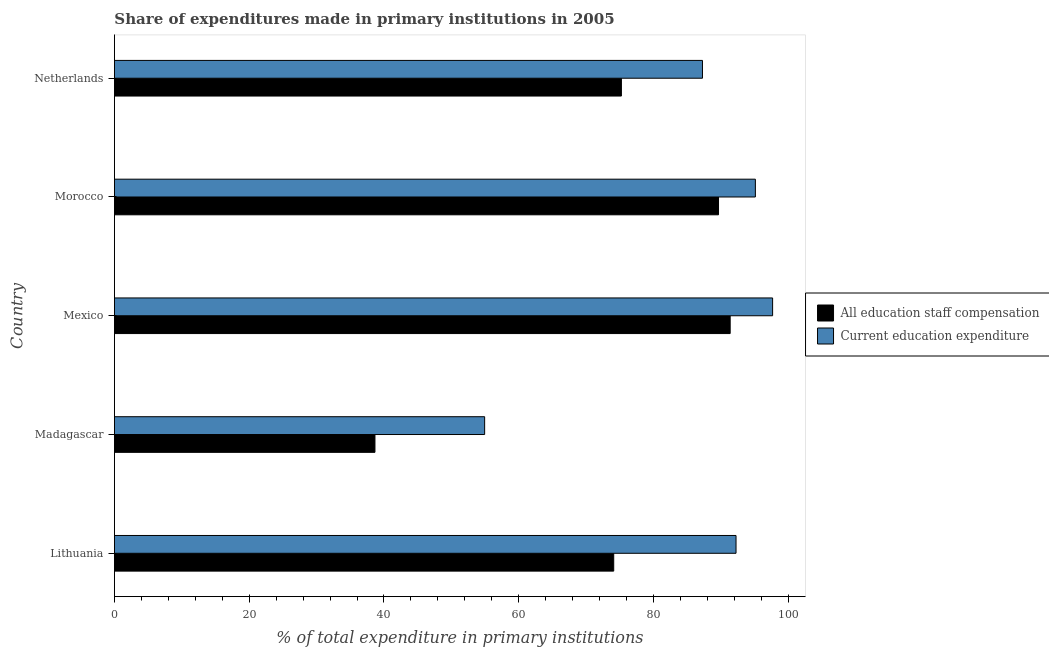How many groups of bars are there?
Your response must be concise. 5. Are the number of bars per tick equal to the number of legend labels?
Ensure brevity in your answer.  Yes. How many bars are there on the 5th tick from the bottom?
Keep it short and to the point. 2. What is the label of the 2nd group of bars from the top?
Give a very brief answer. Morocco. What is the expenditure in staff compensation in Morocco?
Your answer should be very brief. 89.64. Across all countries, what is the maximum expenditure in education?
Keep it short and to the point. 97.67. Across all countries, what is the minimum expenditure in staff compensation?
Keep it short and to the point. 38.66. In which country was the expenditure in staff compensation maximum?
Give a very brief answer. Mexico. In which country was the expenditure in education minimum?
Provide a short and direct response. Madagascar. What is the total expenditure in education in the graph?
Provide a short and direct response. 427.21. What is the difference between the expenditure in staff compensation in Mexico and that in Morocco?
Your response must be concise. 1.73. What is the difference between the expenditure in education in Mexico and the expenditure in staff compensation in Madagascar?
Offer a terse response. 59.01. What is the average expenditure in staff compensation per country?
Give a very brief answer. 73.8. What is the difference between the expenditure in staff compensation and expenditure in education in Lithuania?
Your response must be concise. -18.15. In how many countries, is the expenditure in staff compensation greater than 60 %?
Your answer should be very brief. 4. What is the ratio of the expenditure in staff compensation in Morocco to that in Netherlands?
Provide a short and direct response. 1.19. Is the expenditure in staff compensation in Lithuania less than that in Mexico?
Provide a short and direct response. Yes. What is the difference between the highest and the second highest expenditure in staff compensation?
Give a very brief answer. 1.73. What is the difference between the highest and the lowest expenditure in education?
Your response must be concise. 42.73. In how many countries, is the expenditure in staff compensation greater than the average expenditure in staff compensation taken over all countries?
Provide a short and direct response. 4. What does the 2nd bar from the top in Mexico represents?
Ensure brevity in your answer.  All education staff compensation. What does the 1st bar from the bottom in Madagascar represents?
Provide a short and direct response. All education staff compensation. How many bars are there?
Provide a succinct answer. 10. Does the graph contain any zero values?
Give a very brief answer. No. Does the graph contain grids?
Your response must be concise. No. What is the title of the graph?
Ensure brevity in your answer.  Share of expenditures made in primary institutions in 2005. What is the label or title of the X-axis?
Make the answer very short. % of total expenditure in primary institutions. What is the label or title of the Y-axis?
Ensure brevity in your answer.  Country. What is the % of total expenditure in primary institutions of All education staff compensation in Lithuania?
Offer a terse response. 74.09. What is the % of total expenditure in primary institutions in Current education expenditure in Lithuania?
Offer a very short reply. 92.24. What is the % of total expenditure in primary institutions of All education staff compensation in Madagascar?
Ensure brevity in your answer.  38.66. What is the % of total expenditure in primary institutions in Current education expenditure in Madagascar?
Your answer should be compact. 54.94. What is the % of total expenditure in primary institutions of All education staff compensation in Mexico?
Your response must be concise. 91.37. What is the % of total expenditure in primary institutions of Current education expenditure in Mexico?
Ensure brevity in your answer.  97.67. What is the % of total expenditure in primary institutions in All education staff compensation in Morocco?
Offer a very short reply. 89.64. What is the % of total expenditure in primary institutions of Current education expenditure in Morocco?
Keep it short and to the point. 95.11. What is the % of total expenditure in primary institutions in All education staff compensation in Netherlands?
Keep it short and to the point. 75.23. What is the % of total expenditure in primary institutions in Current education expenditure in Netherlands?
Provide a short and direct response. 87.26. Across all countries, what is the maximum % of total expenditure in primary institutions of All education staff compensation?
Make the answer very short. 91.37. Across all countries, what is the maximum % of total expenditure in primary institutions of Current education expenditure?
Offer a terse response. 97.67. Across all countries, what is the minimum % of total expenditure in primary institutions in All education staff compensation?
Your answer should be very brief. 38.66. Across all countries, what is the minimum % of total expenditure in primary institutions of Current education expenditure?
Give a very brief answer. 54.94. What is the total % of total expenditure in primary institutions of All education staff compensation in the graph?
Give a very brief answer. 368.99. What is the total % of total expenditure in primary institutions of Current education expenditure in the graph?
Your answer should be very brief. 427.21. What is the difference between the % of total expenditure in primary institutions of All education staff compensation in Lithuania and that in Madagascar?
Your response must be concise. 35.43. What is the difference between the % of total expenditure in primary institutions of Current education expenditure in Lithuania and that in Madagascar?
Give a very brief answer. 37.3. What is the difference between the % of total expenditure in primary institutions of All education staff compensation in Lithuania and that in Mexico?
Offer a very short reply. -17.28. What is the difference between the % of total expenditure in primary institutions of Current education expenditure in Lithuania and that in Mexico?
Give a very brief answer. -5.43. What is the difference between the % of total expenditure in primary institutions in All education staff compensation in Lithuania and that in Morocco?
Your response must be concise. -15.55. What is the difference between the % of total expenditure in primary institutions in Current education expenditure in Lithuania and that in Morocco?
Provide a succinct answer. -2.87. What is the difference between the % of total expenditure in primary institutions of All education staff compensation in Lithuania and that in Netherlands?
Provide a short and direct response. -1.14. What is the difference between the % of total expenditure in primary institutions in Current education expenditure in Lithuania and that in Netherlands?
Make the answer very short. 4.98. What is the difference between the % of total expenditure in primary institutions in All education staff compensation in Madagascar and that in Mexico?
Provide a succinct answer. -52.71. What is the difference between the % of total expenditure in primary institutions of Current education expenditure in Madagascar and that in Mexico?
Provide a succinct answer. -42.73. What is the difference between the % of total expenditure in primary institutions of All education staff compensation in Madagascar and that in Morocco?
Your answer should be compact. -50.98. What is the difference between the % of total expenditure in primary institutions of Current education expenditure in Madagascar and that in Morocco?
Offer a very short reply. -40.17. What is the difference between the % of total expenditure in primary institutions in All education staff compensation in Madagascar and that in Netherlands?
Provide a short and direct response. -36.57. What is the difference between the % of total expenditure in primary institutions of Current education expenditure in Madagascar and that in Netherlands?
Provide a short and direct response. -32.32. What is the difference between the % of total expenditure in primary institutions in All education staff compensation in Mexico and that in Morocco?
Provide a short and direct response. 1.73. What is the difference between the % of total expenditure in primary institutions of Current education expenditure in Mexico and that in Morocco?
Your response must be concise. 2.56. What is the difference between the % of total expenditure in primary institutions in All education staff compensation in Mexico and that in Netherlands?
Give a very brief answer. 16.14. What is the difference between the % of total expenditure in primary institutions of Current education expenditure in Mexico and that in Netherlands?
Provide a short and direct response. 10.41. What is the difference between the % of total expenditure in primary institutions of All education staff compensation in Morocco and that in Netherlands?
Provide a succinct answer. 14.41. What is the difference between the % of total expenditure in primary institutions of Current education expenditure in Morocco and that in Netherlands?
Keep it short and to the point. 7.85. What is the difference between the % of total expenditure in primary institutions of All education staff compensation in Lithuania and the % of total expenditure in primary institutions of Current education expenditure in Madagascar?
Provide a short and direct response. 19.15. What is the difference between the % of total expenditure in primary institutions of All education staff compensation in Lithuania and the % of total expenditure in primary institutions of Current education expenditure in Mexico?
Ensure brevity in your answer.  -23.58. What is the difference between the % of total expenditure in primary institutions in All education staff compensation in Lithuania and the % of total expenditure in primary institutions in Current education expenditure in Morocco?
Make the answer very short. -21.02. What is the difference between the % of total expenditure in primary institutions of All education staff compensation in Lithuania and the % of total expenditure in primary institutions of Current education expenditure in Netherlands?
Offer a terse response. -13.17. What is the difference between the % of total expenditure in primary institutions of All education staff compensation in Madagascar and the % of total expenditure in primary institutions of Current education expenditure in Mexico?
Your response must be concise. -59.01. What is the difference between the % of total expenditure in primary institutions in All education staff compensation in Madagascar and the % of total expenditure in primary institutions in Current education expenditure in Morocco?
Offer a terse response. -56.45. What is the difference between the % of total expenditure in primary institutions in All education staff compensation in Madagascar and the % of total expenditure in primary institutions in Current education expenditure in Netherlands?
Provide a succinct answer. -48.6. What is the difference between the % of total expenditure in primary institutions of All education staff compensation in Mexico and the % of total expenditure in primary institutions of Current education expenditure in Morocco?
Keep it short and to the point. -3.74. What is the difference between the % of total expenditure in primary institutions in All education staff compensation in Mexico and the % of total expenditure in primary institutions in Current education expenditure in Netherlands?
Make the answer very short. 4.11. What is the difference between the % of total expenditure in primary institutions of All education staff compensation in Morocco and the % of total expenditure in primary institutions of Current education expenditure in Netherlands?
Provide a short and direct response. 2.38. What is the average % of total expenditure in primary institutions of All education staff compensation per country?
Make the answer very short. 73.8. What is the average % of total expenditure in primary institutions in Current education expenditure per country?
Keep it short and to the point. 85.44. What is the difference between the % of total expenditure in primary institutions in All education staff compensation and % of total expenditure in primary institutions in Current education expenditure in Lithuania?
Offer a very short reply. -18.15. What is the difference between the % of total expenditure in primary institutions of All education staff compensation and % of total expenditure in primary institutions of Current education expenditure in Madagascar?
Give a very brief answer. -16.28. What is the difference between the % of total expenditure in primary institutions in All education staff compensation and % of total expenditure in primary institutions in Current education expenditure in Mexico?
Ensure brevity in your answer.  -6.3. What is the difference between the % of total expenditure in primary institutions of All education staff compensation and % of total expenditure in primary institutions of Current education expenditure in Morocco?
Offer a terse response. -5.47. What is the difference between the % of total expenditure in primary institutions in All education staff compensation and % of total expenditure in primary institutions in Current education expenditure in Netherlands?
Provide a short and direct response. -12.03. What is the ratio of the % of total expenditure in primary institutions in All education staff compensation in Lithuania to that in Madagascar?
Provide a short and direct response. 1.92. What is the ratio of the % of total expenditure in primary institutions in Current education expenditure in Lithuania to that in Madagascar?
Offer a terse response. 1.68. What is the ratio of the % of total expenditure in primary institutions of All education staff compensation in Lithuania to that in Mexico?
Provide a succinct answer. 0.81. What is the ratio of the % of total expenditure in primary institutions in Current education expenditure in Lithuania to that in Mexico?
Your answer should be compact. 0.94. What is the ratio of the % of total expenditure in primary institutions in All education staff compensation in Lithuania to that in Morocco?
Your answer should be compact. 0.83. What is the ratio of the % of total expenditure in primary institutions of Current education expenditure in Lithuania to that in Morocco?
Your answer should be compact. 0.97. What is the ratio of the % of total expenditure in primary institutions in All education staff compensation in Lithuania to that in Netherlands?
Offer a terse response. 0.98. What is the ratio of the % of total expenditure in primary institutions in Current education expenditure in Lithuania to that in Netherlands?
Offer a very short reply. 1.06. What is the ratio of the % of total expenditure in primary institutions of All education staff compensation in Madagascar to that in Mexico?
Give a very brief answer. 0.42. What is the ratio of the % of total expenditure in primary institutions of Current education expenditure in Madagascar to that in Mexico?
Your answer should be very brief. 0.56. What is the ratio of the % of total expenditure in primary institutions of All education staff compensation in Madagascar to that in Morocco?
Keep it short and to the point. 0.43. What is the ratio of the % of total expenditure in primary institutions of Current education expenditure in Madagascar to that in Morocco?
Give a very brief answer. 0.58. What is the ratio of the % of total expenditure in primary institutions in All education staff compensation in Madagascar to that in Netherlands?
Your response must be concise. 0.51. What is the ratio of the % of total expenditure in primary institutions of Current education expenditure in Madagascar to that in Netherlands?
Provide a succinct answer. 0.63. What is the ratio of the % of total expenditure in primary institutions of All education staff compensation in Mexico to that in Morocco?
Keep it short and to the point. 1.02. What is the ratio of the % of total expenditure in primary institutions in Current education expenditure in Mexico to that in Morocco?
Offer a very short reply. 1.03. What is the ratio of the % of total expenditure in primary institutions in All education staff compensation in Mexico to that in Netherlands?
Offer a very short reply. 1.21. What is the ratio of the % of total expenditure in primary institutions of Current education expenditure in Mexico to that in Netherlands?
Offer a terse response. 1.12. What is the ratio of the % of total expenditure in primary institutions of All education staff compensation in Morocco to that in Netherlands?
Give a very brief answer. 1.19. What is the ratio of the % of total expenditure in primary institutions in Current education expenditure in Morocco to that in Netherlands?
Provide a succinct answer. 1.09. What is the difference between the highest and the second highest % of total expenditure in primary institutions in All education staff compensation?
Keep it short and to the point. 1.73. What is the difference between the highest and the second highest % of total expenditure in primary institutions of Current education expenditure?
Provide a succinct answer. 2.56. What is the difference between the highest and the lowest % of total expenditure in primary institutions of All education staff compensation?
Give a very brief answer. 52.71. What is the difference between the highest and the lowest % of total expenditure in primary institutions in Current education expenditure?
Provide a succinct answer. 42.73. 